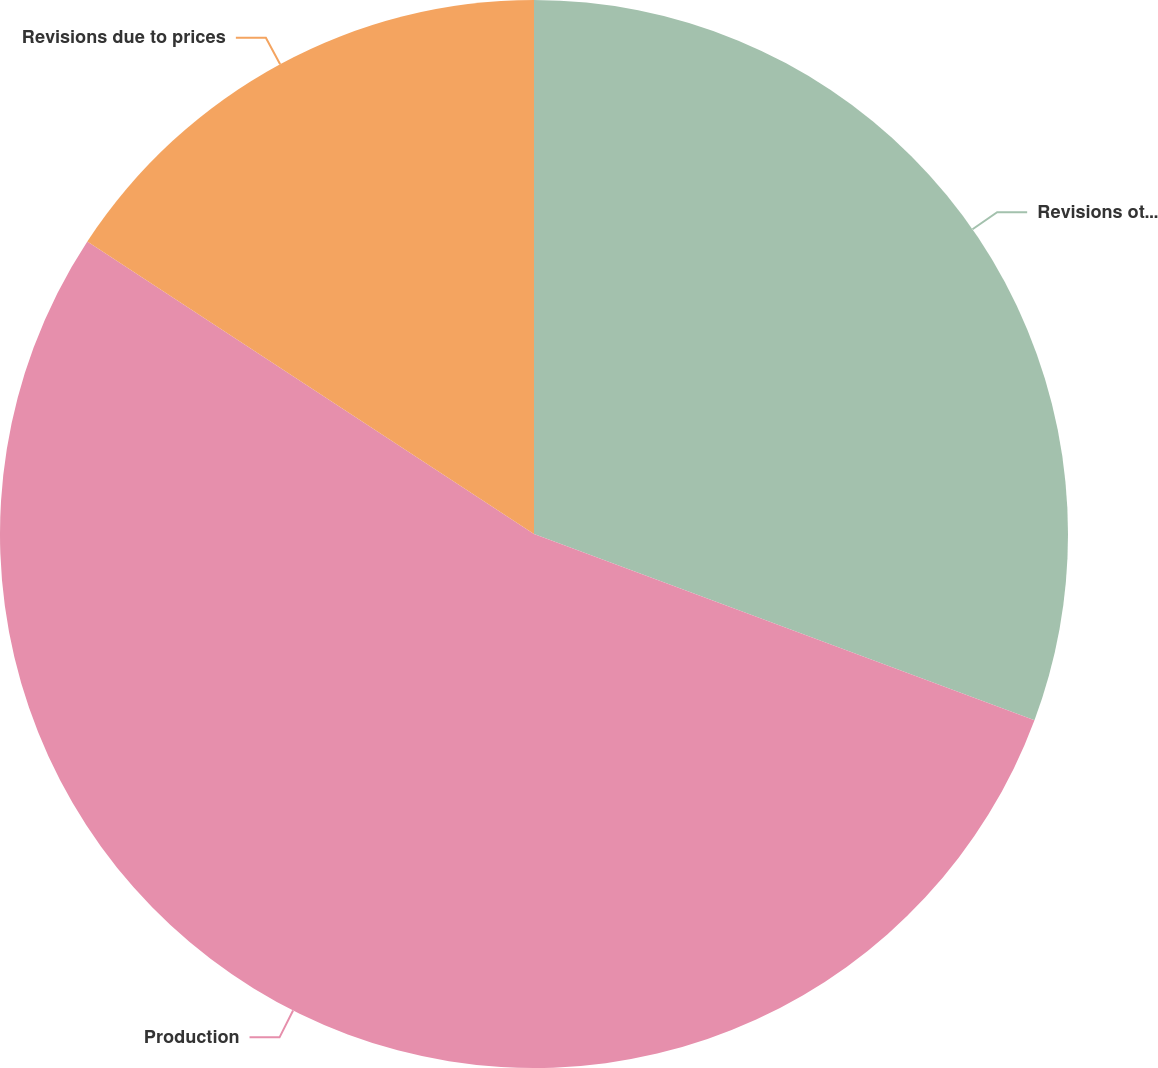Convert chart to OTSL. <chart><loc_0><loc_0><loc_500><loc_500><pie_chart><fcel>Revisions other than price<fcel>Production<fcel>Revisions due to prices<nl><fcel>30.67%<fcel>53.56%<fcel>15.77%<nl></chart> 